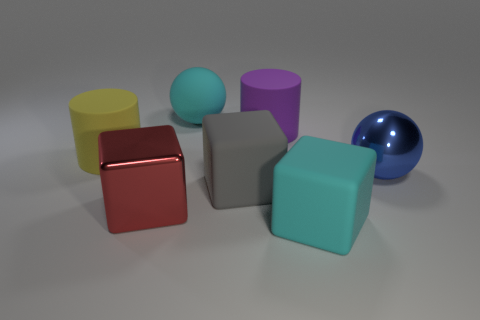How many things are either red balls or big cyan rubber objects to the right of the cyan rubber ball?
Keep it short and to the point. 1. How many other things are the same material as the big gray object?
Provide a short and direct response. 4. How many objects are either yellow matte things or big rubber cubes?
Provide a succinct answer. 3. Are there more rubber spheres that are to the right of the large gray object than cyan balls left of the metallic block?
Ensure brevity in your answer.  No. There is a matte cylinder that is behind the big yellow cylinder; is it the same color as the large metal object in front of the large blue metal ball?
Make the answer very short. No. There is a cylinder that is on the right side of the rubber cylinder that is in front of the rubber cylinder right of the shiny cube; how big is it?
Offer a terse response. Large. There is a metallic object that is the same shape as the gray matte thing; what color is it?
Provide a succinct answer. Red. Is the number of matte cylinders that are in front of the gray matte object greater than the number of small green blocks?
Offer a very short reply. No. Do the purple object and the large cyan rubber object that is in front of the large gray matte cube have the same shape?
Give a very brief answer. No. Is there any other thing that is the same size as the purple cylinder?
Make the answer very short. Yes. 